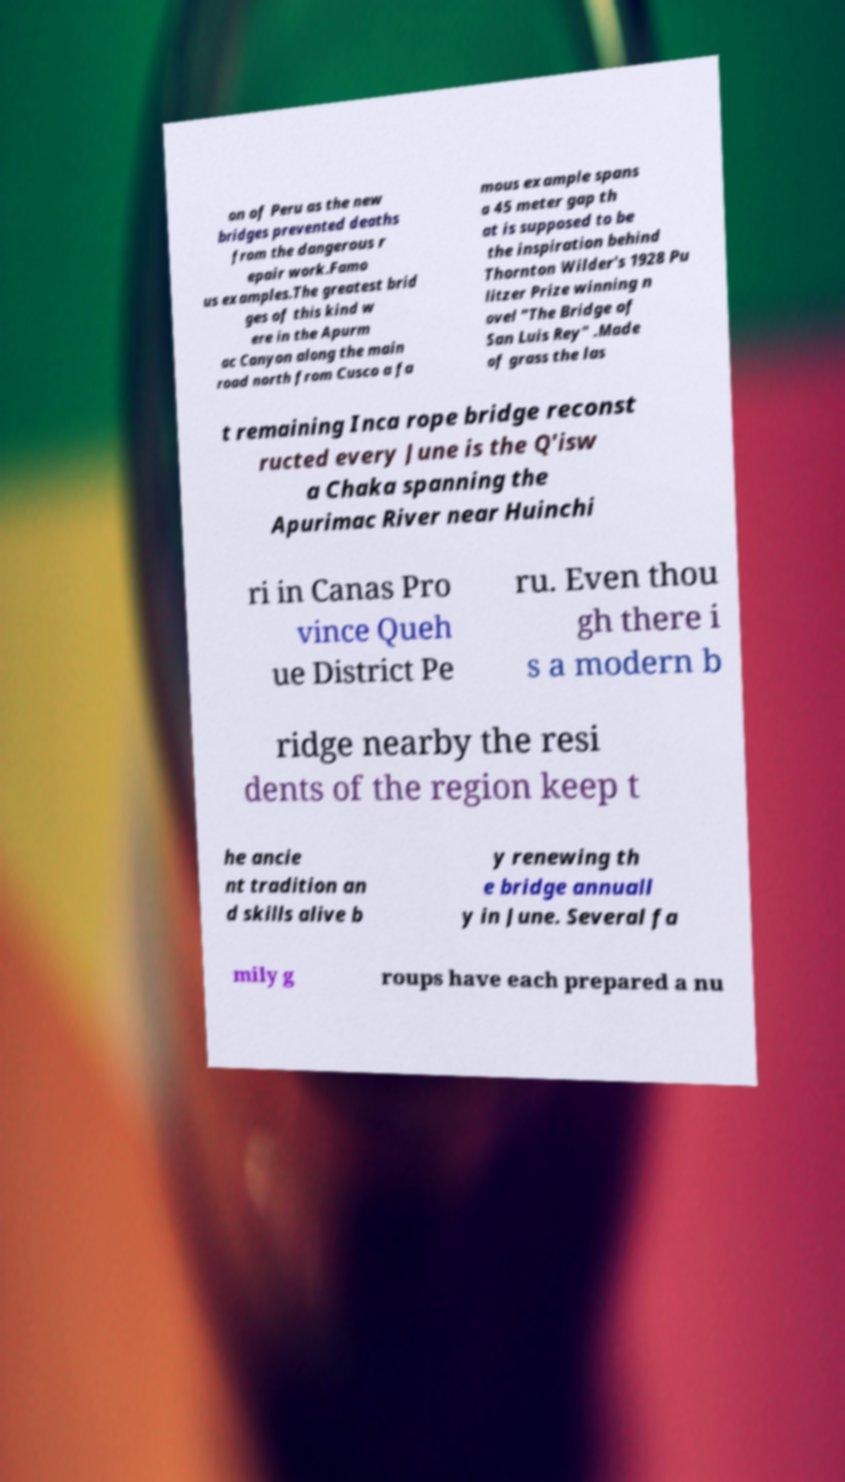Could you extract and type out the text from this image? on of Peru as the new bridges prevented deaths from the dangerous r epair work.Famo us examples.The greatest brid ges of this kind w ere in the Apurm ac Canyon along the main road north from Cusco a fa mous example spans a 45 meter gap th at is supposed to be the inspiration behind Thornton Wilder's 1928 Pu litzer Prize winning n ovel "The Bridge of San Luis Rey" .Made of grass the las t remaining Inca rope bridge reconst ructed every June is the Q'isw a Chaka spanning the Apurimac River near Huinchi ri in Canas Pro vince Queh ue District Pe ru. Even thou gh there i s a modern b ridge nearby the resi dents of the region keep t he ancie nt tradition an d skills alive b y renewing th e bridge annuall y in June. Several fa mily g roups have each prepared a nu 